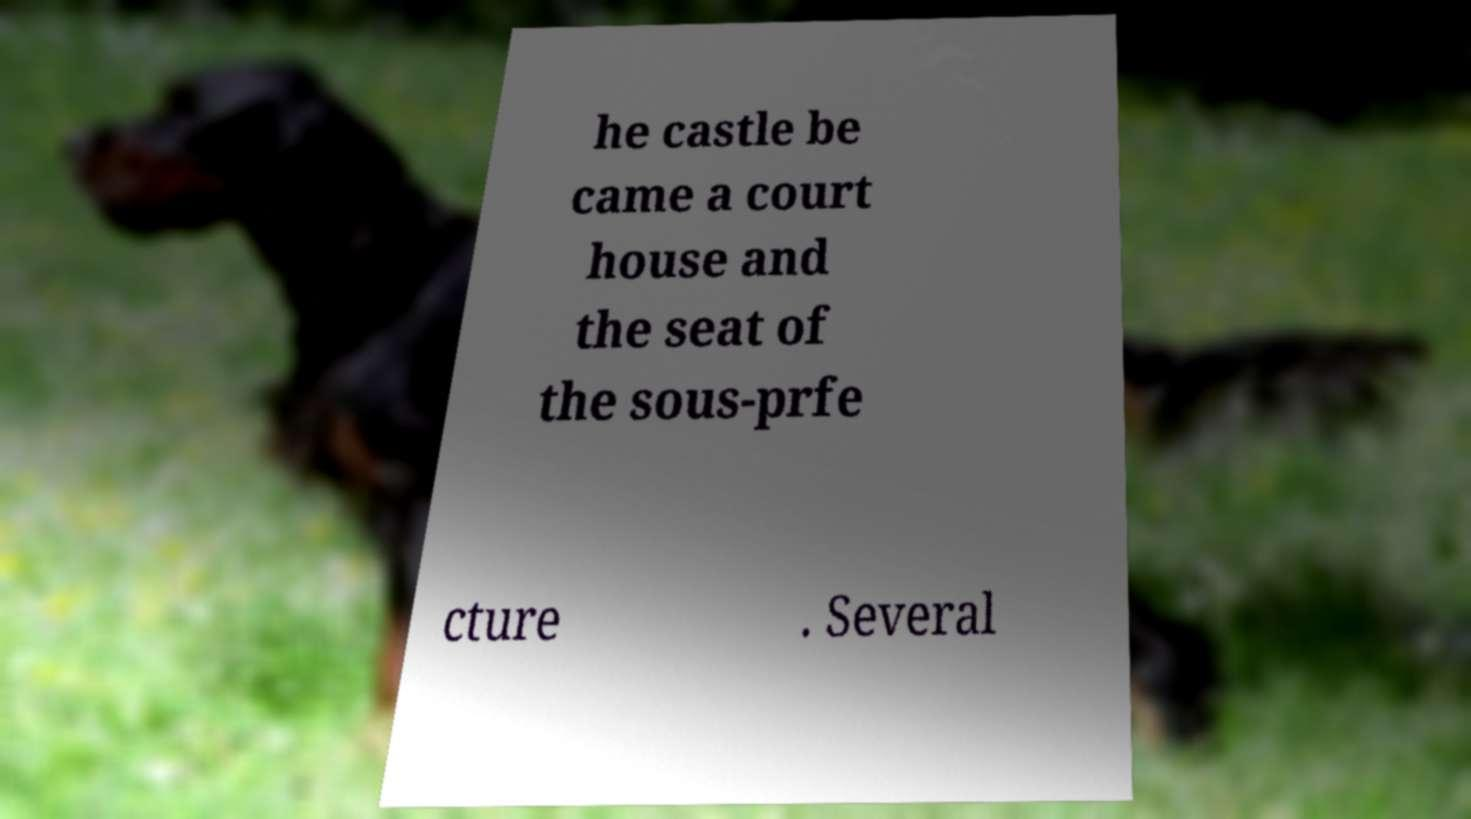I need the written content from this picture converted into text. Can you do that? he castle be came a court house and the seat of the sous-prfe cture . Several 